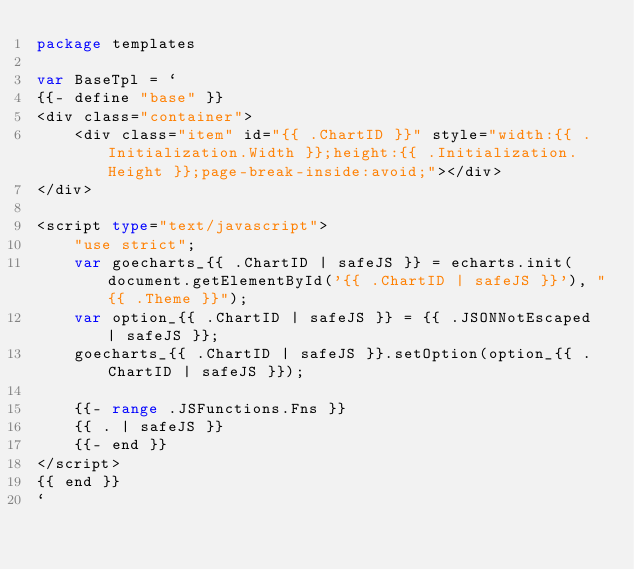<code> <loc_0><loc_0><loc_500><loc_500><_Go_>package templates

var BaseTpl = `
{{- define "base" }}
<div class="container">
    <div class="item" id="{{ .ChartID }}" style="width:{{ .Initialization.Width }};height:{{ .Initialization.Height }};page-break-inside:avoid;"></div>
</div>

<script type="text/javascript">
    "use strict";
    var goecharts_{{ .ChartID | safeJS }} = echarts.init(document.getElementById('{{ .ChartID | safeJS }}'), "{{ .Theme }}");
    var option_{{ .ChartID | safeJS }} = {{ .JSONNotEscaped | safeJS }};
    goecharts_{{ .ChartID | safeJS }}.setOption(option_{{ .ChartID | safeJS }});

    {{- range .JSFunctions.Fns }}
    {{ . | safeJS }}
    {{- end }}
</script>
{{ end }}
`
</code> 